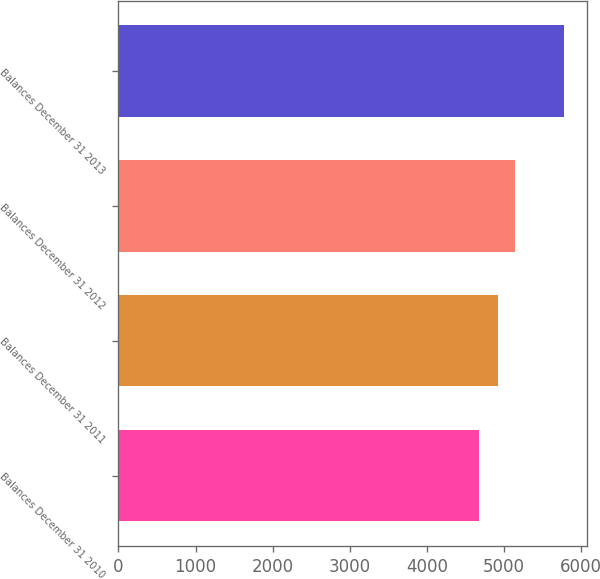Convert chart to OTSL. <chart><loc_0><loc_0><loc_500><loc_500><bar_chart><fcel>Balances December 31 2010<fcel>Balances December 31 2011<fcel>Balances December 31 2012<fcel>Balances December 31 2013<nl><fcel>4680<fcel>4922<fcel>5147<fcel>5784<nl></chart> 